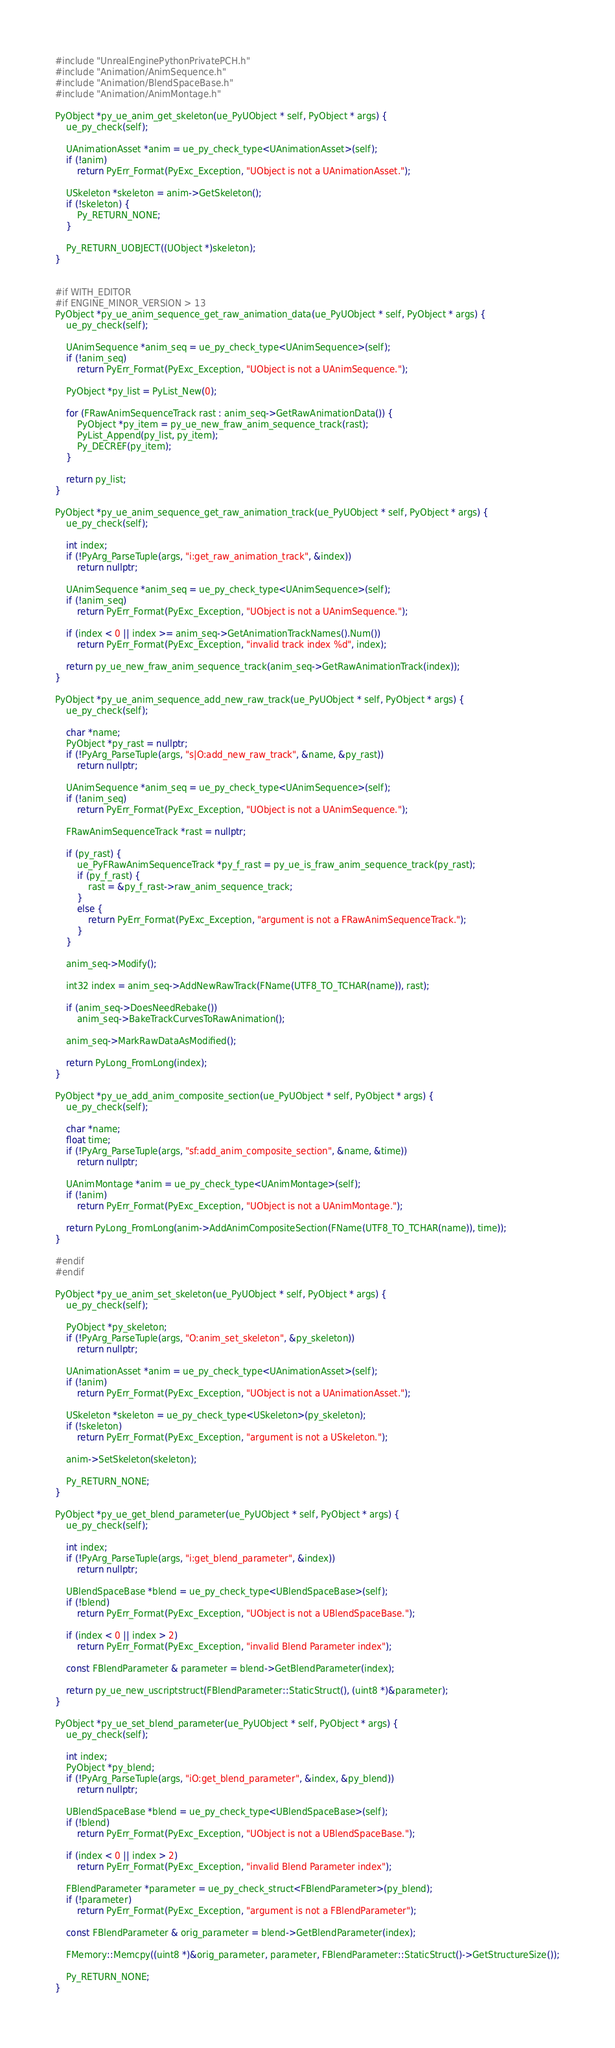Convert code to text. <code><loc_0><loc_0><loc_500><loc_500><_C++_>#include "UnrealEnginePythonPrivatePCH.h"
#include "Animation/AnimSequence.h"
#include "Animation/BlendSpaceBase.h"
#include "Animation/AnimMontage.h"

PyObject *py_ue_anim_get_skeleton(ue_PyUObject * self, PyObject * args) {
	ue_py_check(self);

	UAnimationAsset *anim = ue_py_check_type<UAnimationAsset>(self);
	if (!anim)
		return PyErr_Format(PyExc_Exception, "UObject is not a UAnimationAsset.");

	USkeleton *skeleton = anim->GetSkeleton();
	if (!skeleton) {
		Py_RETURN_NONE;
	}

	Py_RETURN_UOBJECT((UObject *)skeleton);
}


#if WITH_EDITOR
#if ENGINE_MINOR_VERSION > 13
PyObject *py_ue_anim_sequence_get_raw_animation_data(ue_PyUObject * self, PyObject * args) {
	ue_py_check(self);

	UAnimSequence *anim_seq = ue_py_check_type<UAnimSequence>(self);
	if (!anim_seq)
		return PyErr_Format(PyExc_Exception, "UObject is not a UAnimSequence.");

	PyObject *py_list = PyList_New(0);

	for (FRawAnimSequenceTrack rast : anim_seq->GetRawAnimationData()) {
		PyObject *py_item = py_ue_new_fraw_anim_sequence_track(rast);
		PyList_Append(py_list, py_item);
		Py_DECREF(py_item);
	}

	return py_list;
}

PyObject *py_ue_anim_sequence_get_raw_animation_track(ue_PyUObject * self, PyObject * args) {
	ue_py_check(self);

	int index;
	if (!PyArg_ParseTuple(args, "i:get_raw_animation_track", &index))
		return nullptr;

	UAnimSequence *anim_seq = ue_py_check_type<UAnimSequence>(self);
	if (!anim_seq)
		return PyErr_Format(PyExc_Exception, "UObject is not a UAnimSequence.");

	if (index < 0 || index >= anim_seq->GetAnimationTrackNames().Num())
		return PyErr_Format(PyExc_Exception, "invalid track index %d", index);

	return py_ue_new_fraw_anim_sequence_track(anim_seq->GetRawAnimationTrack(index));
}

PyObject *py_ue_anim_sequence_add_new_raw_track(ue_PyUObject * self, PyObject * args) {
	ue_py_check(self);

	char *name;
	PyObject *py_rast = nullptr;
	if (!PyArg_ParseTuple(args, "s|O:add_new_raw_track", &name, &py_rast))
		return nullptr;

	UAnimSequence *anim_seq = ue_py_check_type<UAnimSequence>(self);
	if (!anim_seq)
		return PyErr_Format(PyExc_Exception, "UObject is not a UAnimSequence.");

	FRawAnimSequenceTrack *rast = nullptr;

	if (py_rast) {
		ue_PyFRawAnimSequenceTrack *py_f_rast = py_ue_is_fraw_anim_sequence_track(py_rast);
		if (py_f_rast) {
			rast = &py_f_rast->raw_anim_sequence_track;
		}
		else {
			return PyErr_Format(PyExc_Exception, "argument is not a FRawAnimSequenceTrack.");
		}
	}

	anim_seq->Modify();

	int32 index = anim_seq->AddNewRawTrack(FName(UTF8_TO_TCHAR(name)), rast);

	if (anim_seq->DoesNeedRebake())
		anim_seq->BakeTrackCurvesToRawAnimation();

	anim_seq->MarkRawDataAsModified();

	return PyLong_FromLong(index);
}

PyObject *py_ue_add_anim_composite_section(ue_PyUObject * self, PyObject * args) {
    ue_py_check(self);

    char *name;
    float time;
    if (!PyArg_ParseTuple(args, "sf:add_anim_composite_section", &name, &time))
        return nullptr;

    UAnimMontage *anim = ue_py_check_type<UAnimMontage>(self);
    if (!anim)
        return PyErr_Format(PyExc_Exception, "UObject is not a UAnimMontage.");

    return PyLong_FromLong(anim->AddAnimCompositeSection(FName(UTF8_TO_TCHAR(name)), time));
}

#endif
#endif

PyObject *py_ue_anim_set_skeleton(ue_PyUObject * self, PyObject * args) {
	ue_py_check(self);

	PyObject *py_skeleton;
	if (!PyArg_ParseTuple(args, "O:anim_set_skeleton", &py_skeleton))
		return nullptr;

	UAnimationAsset *anim = ue_py_check_type<UAnimationAsset>(self);
	if (!anim)
		return PyErr_Format(PyExc_Exception, "UObject is not a UAnimationAsset.");

	USkeleton *skeleton = ue_py_check_type<USkeleton>(py_skeleton);
	if (!skeleton)
		return PyErr_Format(PyExc_Exception, "argument is not a USkeleton.");

	anim->SetSkeleton(skeleton);
	
	Py_RETURN_NONE;
}

PyObject *py_ue_get_blend_parameter(ue_PyUObject * self, PyObject * args) {
	ue_py_check(self);

	int index;
	if (!PyArg_ParseTuple(args, "i:get_blend_parameter", &index))
		return nullptr;

	UBlendSpaceBase *blend = ue_py_check_type<UBlendSpaceBase>(self);
	if (!blend)
		return PyErr_Format(PyExc_Exception, "UObject is not a UBlendSpaceBase.");

	if (index < 0 || index > 2)
		return PyErr_Format(PyExc_Exception, "invalid Blend Parameter index");

	const FBlendParameter & parameter = blend->GetBlendParameter(index);

	return py_ue_new_uscriptstruct(FBlendParameter::StaticStruct(), (uint8 *)&parameter);
}

PyObject *py_ue_set_blend_parameter(ue_PyUObject * self, PyObject * args) {
	ue_py_check(self);

	int index;
	PyObject *py_blend;
	if (!PyArg_ParseTuple(args, "iO:get_blend_parameter", &index, &py_blend))
		return nullptr;

	UBlendSpaceBase *blend = ue_py_check_type<UBlendSpaceBase>(self);
	if (!blend)
		return PyErr_Format(PyExc_Exception, "UObject is not a UBlendSpaceBase.");

	if (index < 0 || index > 2)
		return PyErr_Format(PyExc_Exception, "invalid Blend Parameter index");

	FBlendParameter *parameter = ue_py_check_struct<FBlendParameter>(py_blend);
	if (!parameter)
		return PyErr_Format(PyExc_Exception, "argument is not a FBlendParameter");

	const FBlendParameter & orig_parameter = blend->GetBlendParameter(index);

	FMemory::Memcpy((uint8 *)&orig_parameter, parameter, FBlendParameter::StaticStruct()->GetStructureSize());

	Py_RETURN_NONE;
}
</code> 